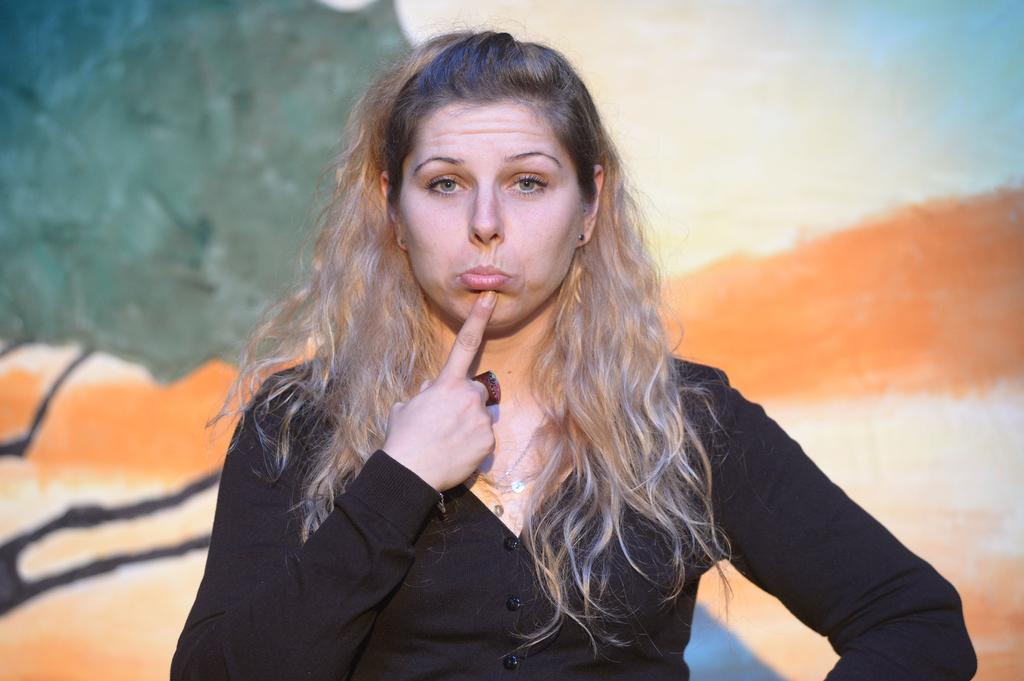Who is the main subject in the image? There is a woman in the image. What is the woman doing in the image? The woman is standing. What is the woman wearing in the image? The woman is wearing a black t-shirt. What advice does the woman give to the person on the roof in the image? There is no person on the roof in the image, and the woman is not giving any advice. 